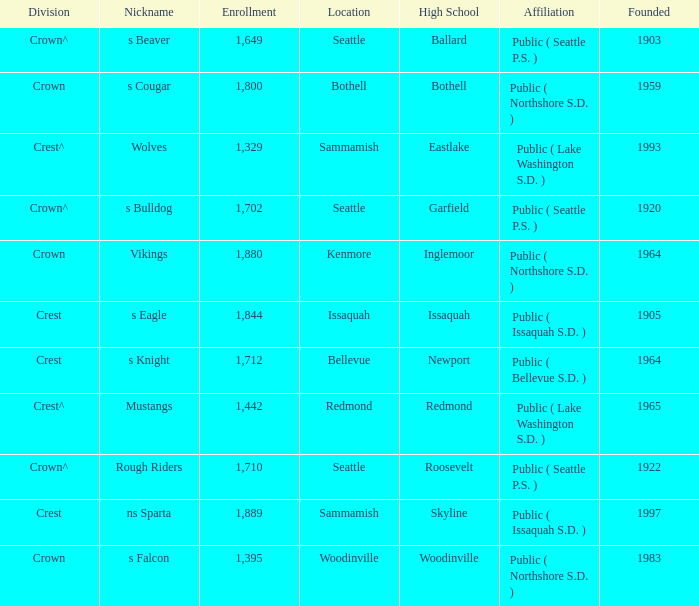What High School with a nickname of S Eagle has a Division of crest? Issaquah. 